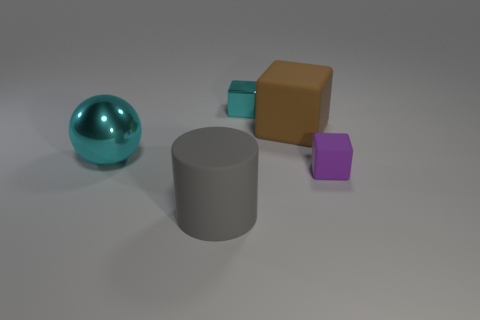Add 3 large gray matte cylinders. How many objects exist? 8 Subtract all matte cubes. How many cubes are left? 1 Subtract all balls. How many objects are left? 4 Add 4 balls. How many balls are left? 5 Add 4 tiny green blocks. How many tiny green blocks exist? 4 Subtract all purple blocks. How many blocks are left? 2 Subtract 0 red spheres. How many objects are left? 5 Subtract 1 balls. How many balls are left? 0 Subtract all blue blocks. Subtract all yellow balls. How many blocks are left? 3 Subtract all gray rubber cylinders. Subtract all rubber things. How many objects are left? 1 